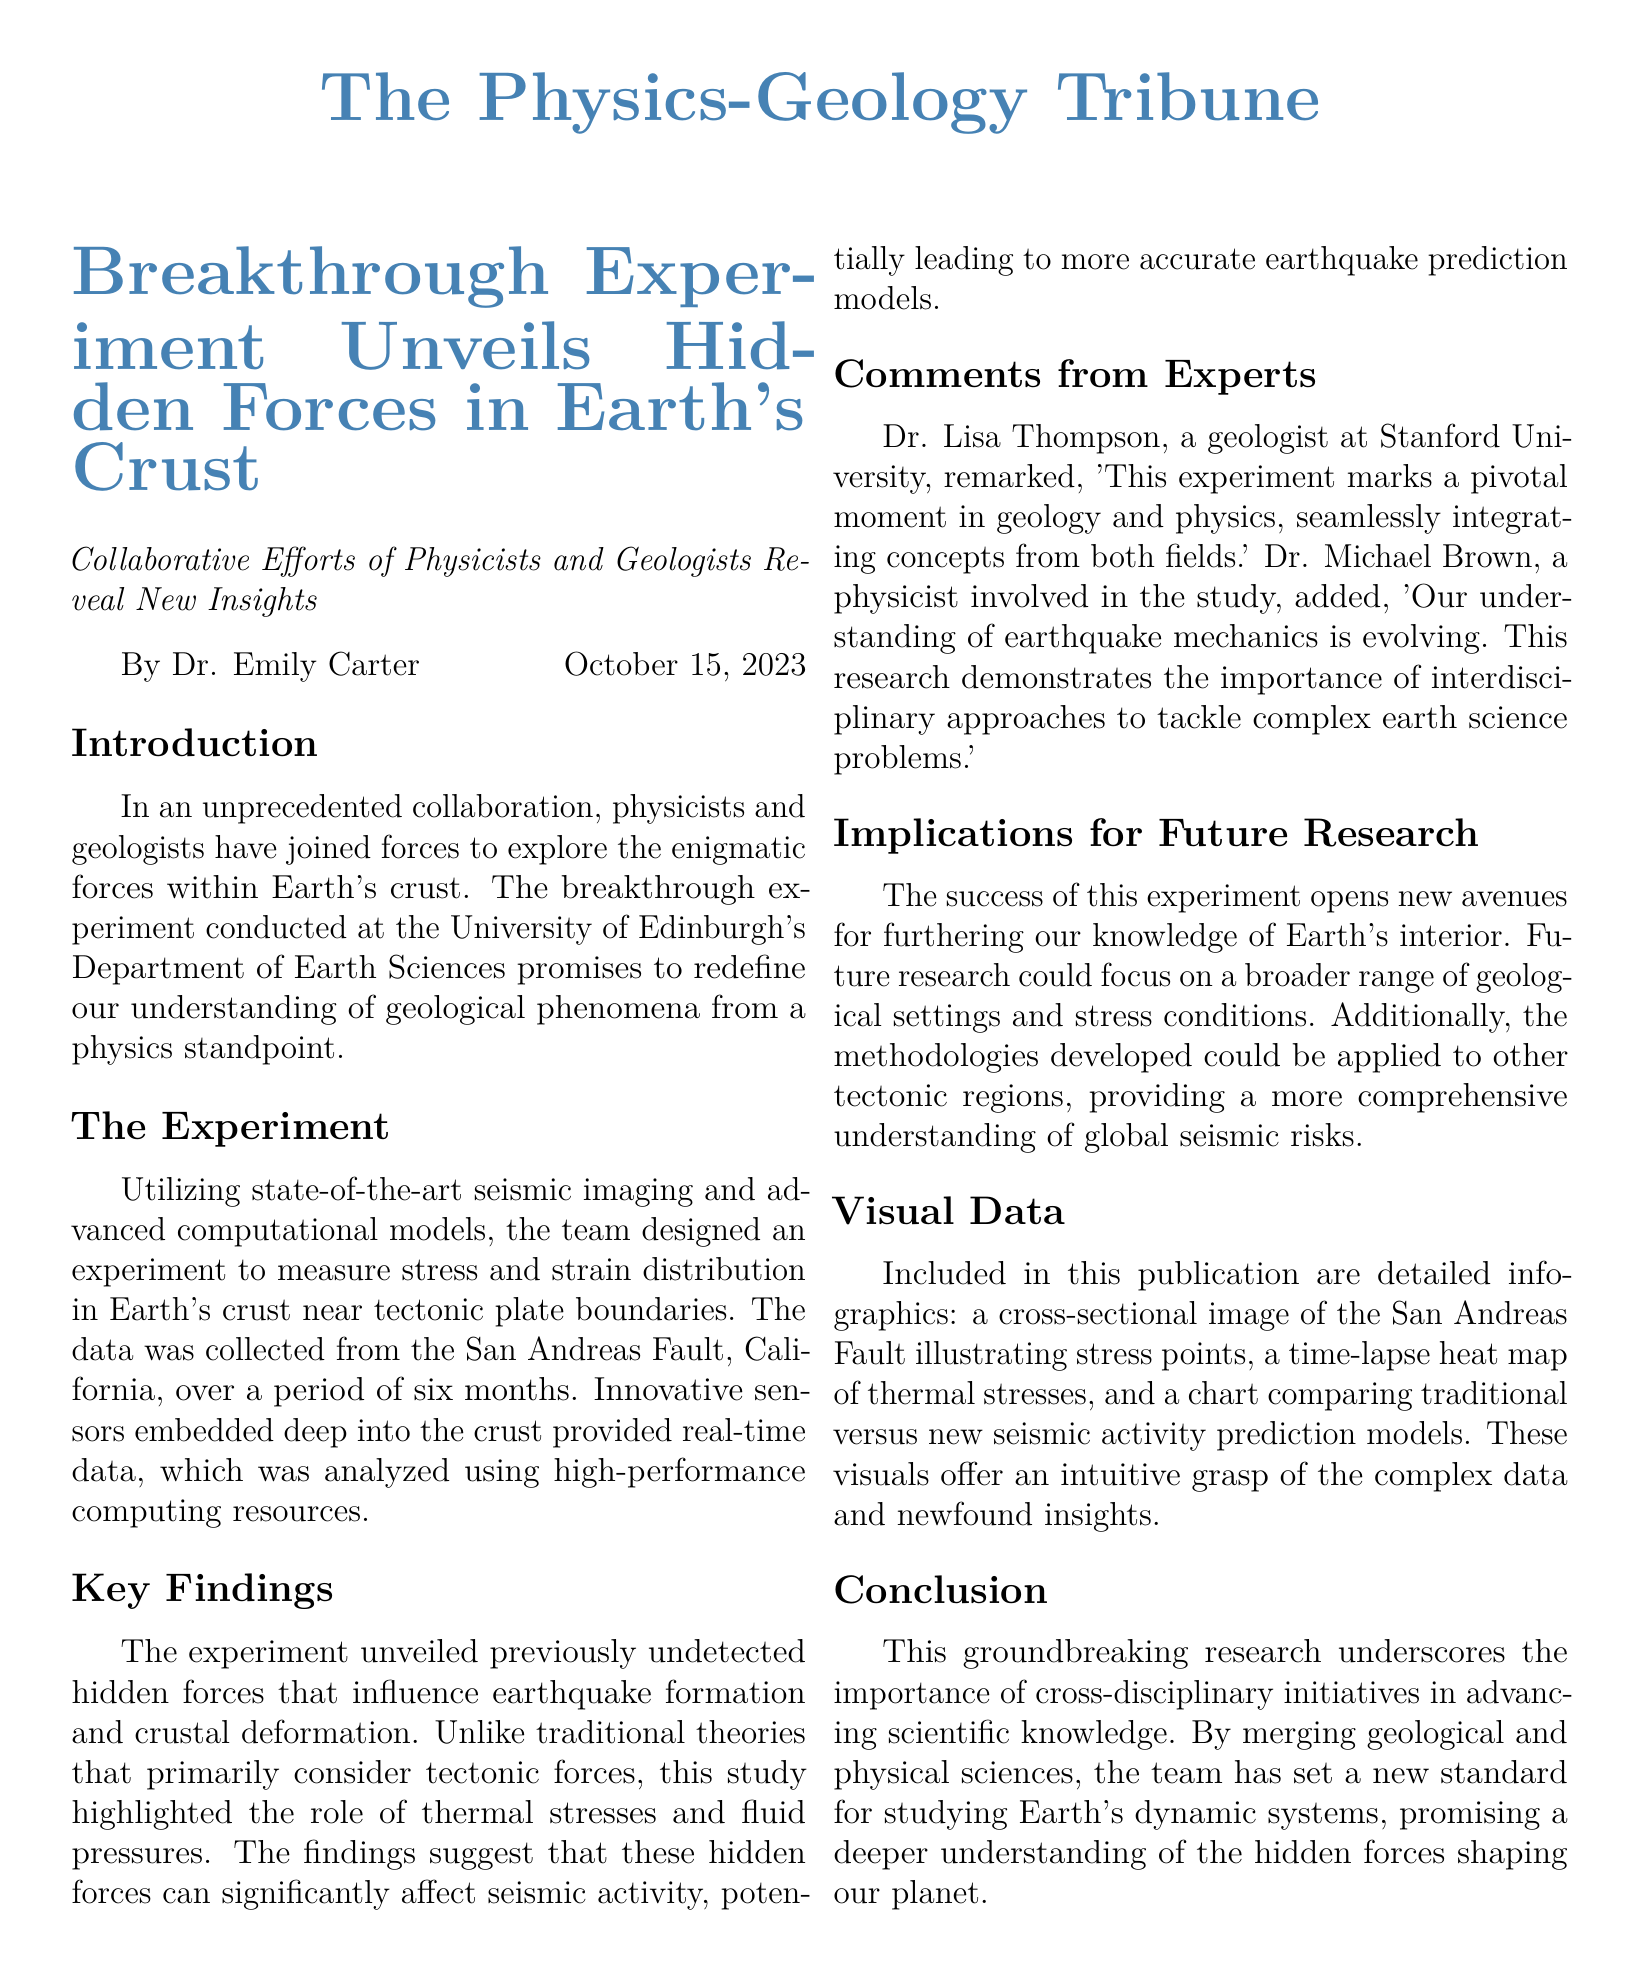What is the title of the article? The title of the article is stated at the beginning of the document in bold.
Answer: Breakthrough Experiment Unveils Hidden Forces in Earth's Crust Who conducted the experiment? The document mentions the collaborative efforts of physicists and geologists specifically at the University of Edinburgh's Department of Earth Sciences.
Answer: University of Edinburgh What type of sensors were used in the experiment? The document refers to "innovative sensors" that were embedded deep into the crust to collect real-time data.
Answer: Innovative sensors How long was the data collection period? It is explicitly stated in the document that the data was collected over a period of six months.
Answer: Six months What role besides tectonic forces was highlighted in the findings? The findings emphasized the importance of additional factors impacting seismic activity.
Answer: Thermal stresses and fluid pressures Which fault was the focus of the study? The document identifies a specific geographical feature that was the subject of the research.
Answer: San Andreas Fault What does Dr. Lisa Thompson compare this experiment to? Dr. Lisa Thompson remarks on the significance of this experiment in the context of interdisciplinary collaboration.
Answer: Pivotal moment What type of publication is this document? The structure and content of the document indicate its purpose and style, typical of a news publication.
Answer: Newspaper layout 